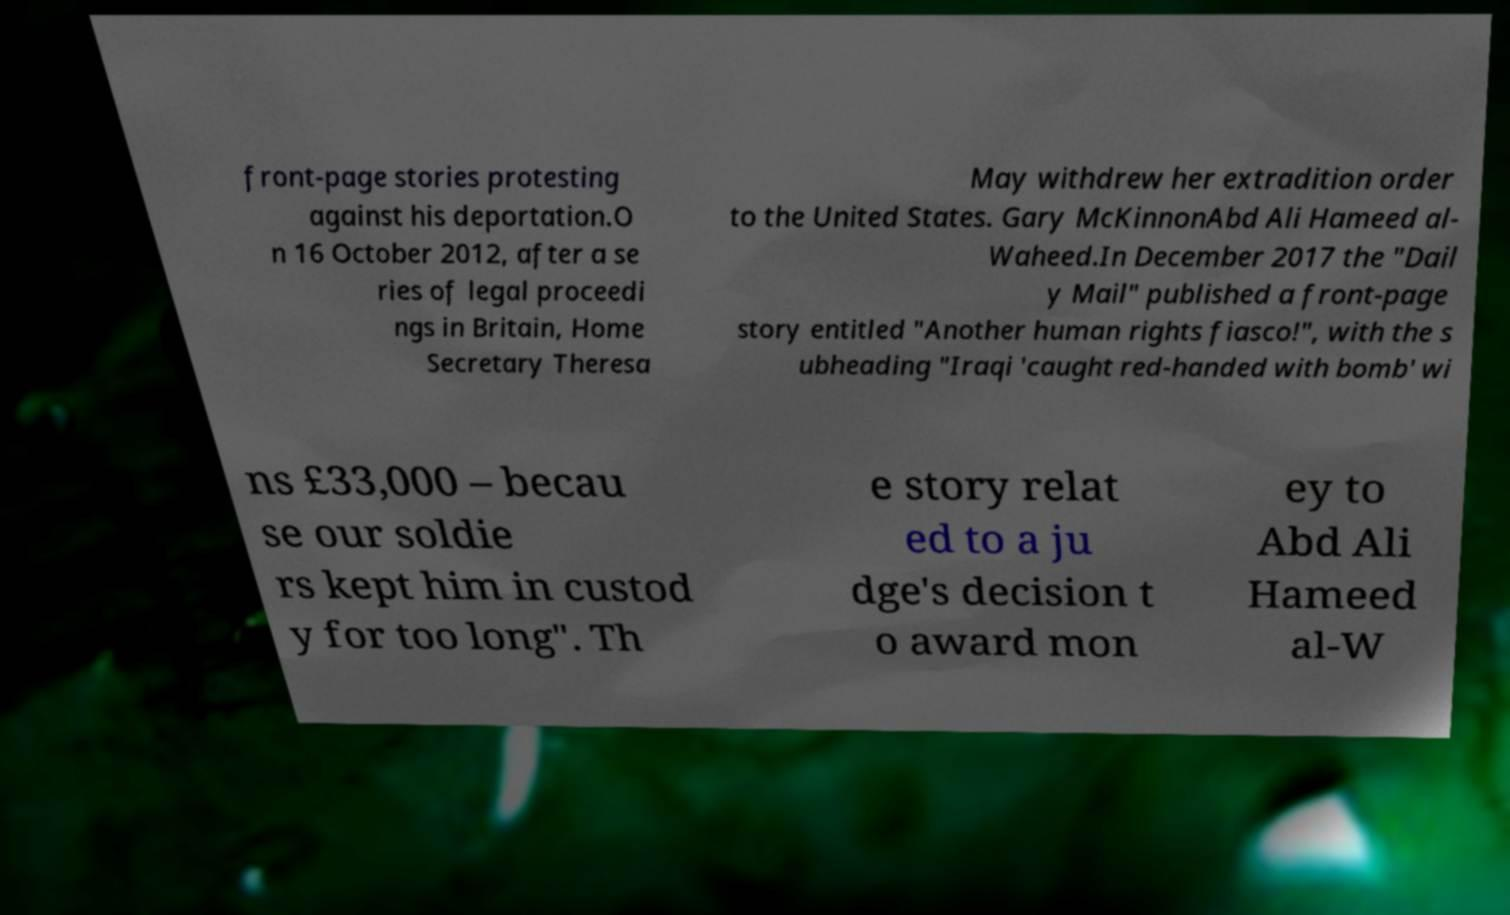For documentation purposes, I need the text within this image transcribed. Could you provide that? front-page stories protesting against his deportation.O n 16 October 2012, after a se ries of legal proceedi ngs in Britain, Home Secretary Theresa May withdrew her extradition order to the United States. Gary McKinnonAbd Ali Hameed al- Waheed.In December 2017 the "Dail y Mail" published a front-page story entitled "Another human rights fiasco!", with the s ubheading "Iraqi 'caught red-handed with bomb' wi ns £33,000 – becau se our soldie rs kept him in custod y for too long". Th e story relat ed to a ju dge's decision t o award mon ey to Abd Ali Hameed al-W 